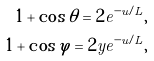Convert formula to latex. <formula><loc_0><loc_0><loc_500><loc_500>1 + \cos \theta = 2 e ^ { - u / L } , \\ 1 + \cos \varphi = 2 y e ^ { - u / L } ,</formula> 